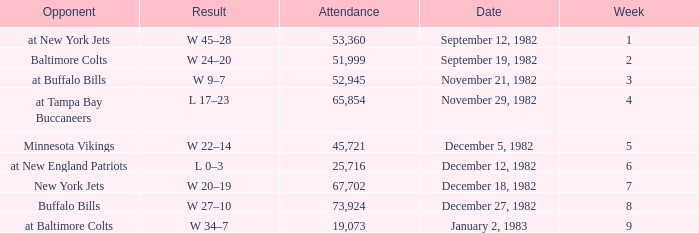What week was the game on September 12, 1982 with an attendance greater than 51,999? 1.0. 